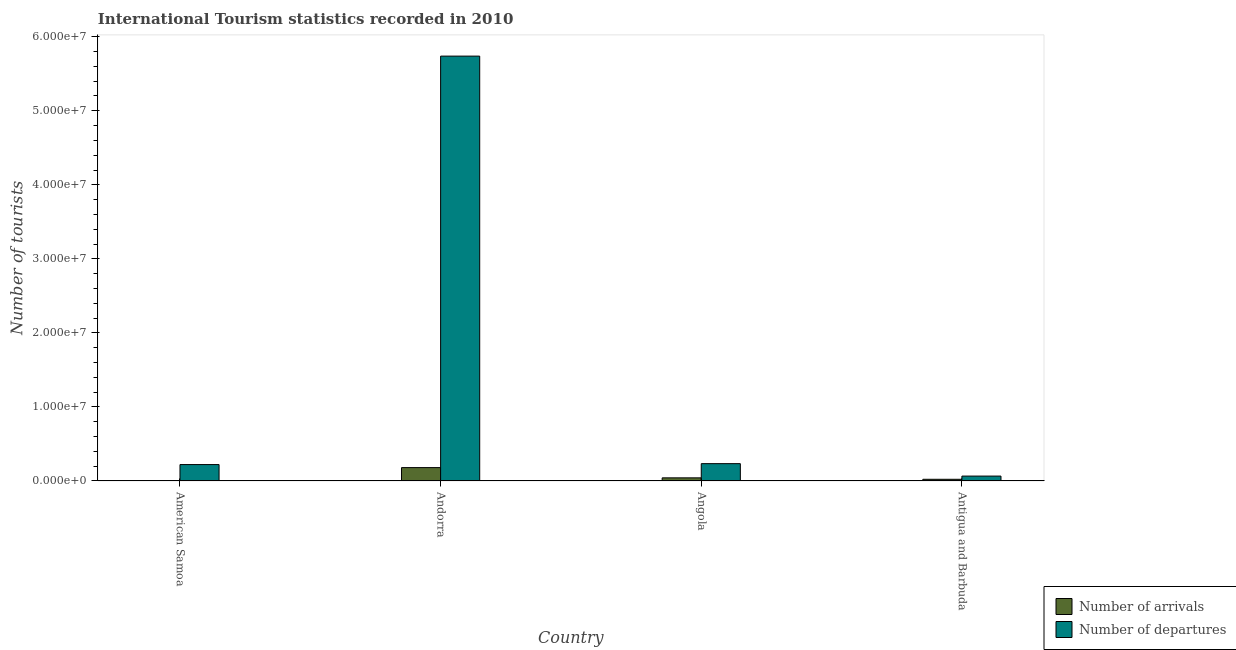How many different coloured bars are there?
Give a very brief answer. 2. How many groups of bars are there?
Your response must be concise. 4. Are the number of bars per tick equal to the number of legend labels?
Your answer should be compact. Yes. Are the number of bars on each tick of the X-axis equal?
Make the answer very short. Yes. How many bars are there on the 3rd tick from the left?
Provide a short and direct response. 2. What is the label of the 1st group of bars from the left?
Your response must be concise. American Samoa. What is the number of tourist arrivals in Antigua and Barbuda?
Your answer should be compact. 2.30e+05. Across all countries, what is the maximum number of tourist arrivals?
Make the answer very short. 1.81e+06. Across all countries, what is the minimum number of tourist departures?
Make the answer very short. 6.62e+05. In which country was the number of tourist departures maximum?
Your answer should be very brief. Andorra. In which country was the number of tourist departures minimum?
Your response must be concise. Antigua and Barbuda. What is the total number of tourist departures in the graph?
Offer a very short reply. 6.26e+07. What is the difference between the number of tourist arrivals in American Samoa and that in Angola?
Offer a very short reply. -4.02e+05. What is the difference between the number of tourist arrivals in Antigua and Barbuda and the number of tourist departures in American Samoa?
Provide a short and direct response. -1.99e+06. What is the average number of tourist departures per country?
Your answer should be very brief. 1.57e+07. What is the difference between the number of tourist arrivals and number of tourist departures in American Samoa?
Offer a very short reply. -2.20e+06. What is the ratio of the number of tourist arrivals in American Samoa to that in Angola?
Give a very brief answer. 0.05. Is the number of tourist arrivals in American Samoa less than that in Angola?
Ensure brevity in your answer.  Yes. What is the difference between the highest and the second highest number of tourist departures?
Ensure brevity in your answer.  5.50e+07. What is the difference between the highest and the lowest number of tourist departures?
Offer a very short reply. 5.67e+07. What does the 2nd bar from the left in American Samoa represents?
Offer a terse response. Number of departures. What does the 1st bar from the right in Angola represents?
Provide a succinct answer. Number of departures. Are all the bars in the graph horizontal?
Provide a succinct answer. No. What is the difference between two consecutive major ticks on the Y-axis?
Give a very brief answer. 1.00e+07. Are the values on the major ticks of Y-axis written in scientific E-notation?
Provide a succinct answer. Yes. Does the graph contain any zero values?
Your answer should be very brief. No. How many legend labels are there?
Provide a succinct answer. 2. What is the title of the graph?
Ensure brevity in your answer.  International Tourism statistics recorded in 2010. Does "Official aid received" appear as one of the legend labels in the graph?
Your response must be concise. No. What is the label or title of the X-axis?
Provide a short and direct response. Country. What is the label or title of the Y-axis?
Provide a short and direct response. Number of tourists. What is the Number of tourists of Number of arrivals in American Samoa?
Offer a very short reply. 2.26e+04. What is the Number of tourists of Number of departures in American Samoa?
Offer a terse response. 2.22e+06. What is the Number of tourists of Number of arrivals in Andorra?
Ensure brevity in your answer.  1.81e+06. What is the Number of tourists of Number of departures in Andorra?
Keep it short and to the point. 5.74e+07. What is the Number of tourists in Number of arrivals in Angola?
Your answer should be very brief. 4.25e+05. What is the Number of tourists in Number of departures in Angola?
Offer a terse response. 2.34e+06. What is the Number of tourists in Number of arrivals in Antigua and Barbuda?
Keep it short and to the point. 2.30e+05. What is the Number of tourists in Number of departures in Antigua and Barbuda?
Ensure brevity in your answer.  6.62e+05. Across all countries, what is the maximum Number of tourists in Number of arrivals?
Keep it short and to the point. 1.81e+06. Across all countries, what is the maximum Number of tourists in Number of departures?
Ensure brevity in your answer.  5.74e+07. Across all countries, what is the minimum Number of tourists in Number of arrivals?
Your response must be concise. 2.26e+04. Across all countries, what is the minimum Number of tourists of Number of departures?
Your answer should be very brief. 6.62e+05. What is the total Number of tourists in Number of arrivals in the graph?
Offer a terse response. 2.49e+06. What is the total Number of tourists of Number of departures in the graph?
Your answer should be compact. 6.26e+07. What is the difference between the Number of tourists in Number of arrivals in American Samoa and that in Andorra?
Offer a very short reply. -1.79e+06. What is the difference between the Number of tourists in Number of departures in American Samoa and that in Andorra?
Make the answer very short. -5.52e+07. What is the difference between the Number of tourists in Number of arrivals in American Samoa and that in Angola?
Ensure brevity in your answer.  -4.02e+05. What is the difference between the Number of tourists in Number of departures in American Samoa and that in Angola?
Your response must be concise. -1.23e+05. What is the difference between the Number of tourists of Number of arrivals in American Samoa and that in Antigua and Barbuda?
Offer a very short reply. -2.07e+05. What is the difference between the Number of tourists in Number of departures in American Samoa and that in Antigua and Barbuda?
Give a very brief answer. 1.56e+06. What is the difference between the Number of tourists of Number of arrivals in Andorra and that in Angola?
Offer a very short reply. 1.38e+06. What is the difference between the Number of tourists in Number of departures in Andorra and that in Angola?
Give a very brief answer. 5.50e+07. What is the difference between the Number of tourists of Number of arrivals in Andorra and that in Antigua and Barbuda?
Make the answer very short. 1.58e+06. What is the difference between the Number of tourists of Number of departures in Andorra and that in Antigua and Barbuda?
Offer a terse response. 5.67e+07. What is the difference between the Number of tourists of Number of arrivals in Angola and that in Antigua and Barbuda?
Make the answer very short. 1.95e+05. What is the difference between the Number of tourists of Number of departures in Angola and that in Antigua and Barbuda?
Offer a very short reply. 1.68e+06. What is the difference between the Number of tourists of Number of arrivals in American Samoa and the Number of tourists of Number of departures in Andorra?
Provide a succinct answer. -5.74e+07. What is the difference between the Number of tourists in Number of arrivals in American Samoa and the Number of tourists in Number of departures in Angola?
Your answer should be compact. -2.32e+06. What is the difference between the Number of tourists in Number of arrivals in American Samoa and the Number of tourists in Number of departures in Antigua and Barbuda?
Offer a terse response. -6.39e+05. What is the difference between the Number of tourists of Number of arrivals in Andorra and the Number of tourists of Number of departures in Angola?
Your answer should be very brief. -5.34e+05. What is the difference between the Number of tourists in Number of arrivals in Andorra and the Number of tourists in Number of departures in Antigua and Barbuda?
Make the answer very short. 1.15e+06. What is the difference between the Number of tourists in Number of arrivals in Angola and the Number of tourists in Number of departures in Antigua and Barbuda?
Offer a terse response. -2.37e+05. What is the average Number of tourists of Number of arrivals per country?
Make the answer very short. 6.21e+05. What is the average Number of tourists of Number of departures per country?
Give a very brief answer. 1.57e+07. What is the difference between the Number of tourists in Number of arrivals and Number of tourists in Number of departures in American Samoa?
Offer a very short reply. -2.20e+06. What is the difference between the Number of tourists of Number of arrivals and Number of tourists of Number of departures in Andorra?
Your response must be concise. -5.56e+07. What is the difference between the Number of tourists in Number of arrivals and Number of tourists in Number of departures in Angola?
Your answer should be very brief. -1.92e+06. What is the difference between the Number of tourists in Number of arrivals and Number of tourists in Number of departures in Antigua and Barbuda?
Offer a very short reply. -4.32e+05. What is the ratio of the Number of tourists in Number of arrivals in American Samoa to that in Andorra?
Provide a succinct answer. 0.01. What is the ratio of the Number of tourists in Number of departures in American Samoa to that in Andorra?
Provide a succinct answer. 0.04. What is the ratio of the Number of tourists of Number of arrivals in American Samoa to that in Angola?
Offer a very short reply. 0.05. What is the ratio of the Number of tourists in Number of departures in American Samoa to that in Angola?
Give a very brief answer. 0.95. What is the ratio of the Number of tourists of Number of arrivals in American Samoa to that in Antigua and Barbuda?
Offer a very short reply. 0.1. What is the ratio of the Number of tourists of Number of departures in American Samoa to that in Antigua and Barbuda?
Provide a short and direct response. 3.35. What is the ratio of the Number of tourists in Number of arrivals in Andorra to that in Angola?
Provide a short and direct response. 4.25. What is the ratio of the Number of tourists of Number of departures in Andorra to that in Angola?
Provide a short and direct response. 24.5. What is the ratio of the Number of tourists of Number of arrivals in Andorra to that in Antigua and Barbuda?
Provide a short and direct response. 7.86. What is the ratio of the Number of tourists of Number of departures in Andorra to that in Antigua and Barbuda?
Your response must be concise. 86.69. What is the ratio of the Number of tourists of Number of arrivals in Angola to that in Antigua and Barbuda?
Ensure brevity in your answer.  1.85. What is the ratio of the Number of tourists in Number of departures in Angola to that in Antigua and Barbuda?
Your answer should be compact. 3.54. What is the difference between the highest and the second highest Number of tourists of Number of arrivals?
Provide a short and direct response. 1.38e+06. What is the difference between the highest and the second highest Number of tourists of Number of departures?
Make the answer very short. 5.50e+07. What is the difference between the highest and the lowest Number of tourists in Number of arrivals?
Ensure brevity in your answer.  1.79e+06. What is the difference between the highest and the lowest Number of tourists of Number of departures?
Provide a succinct answer. 5.67e+07. 